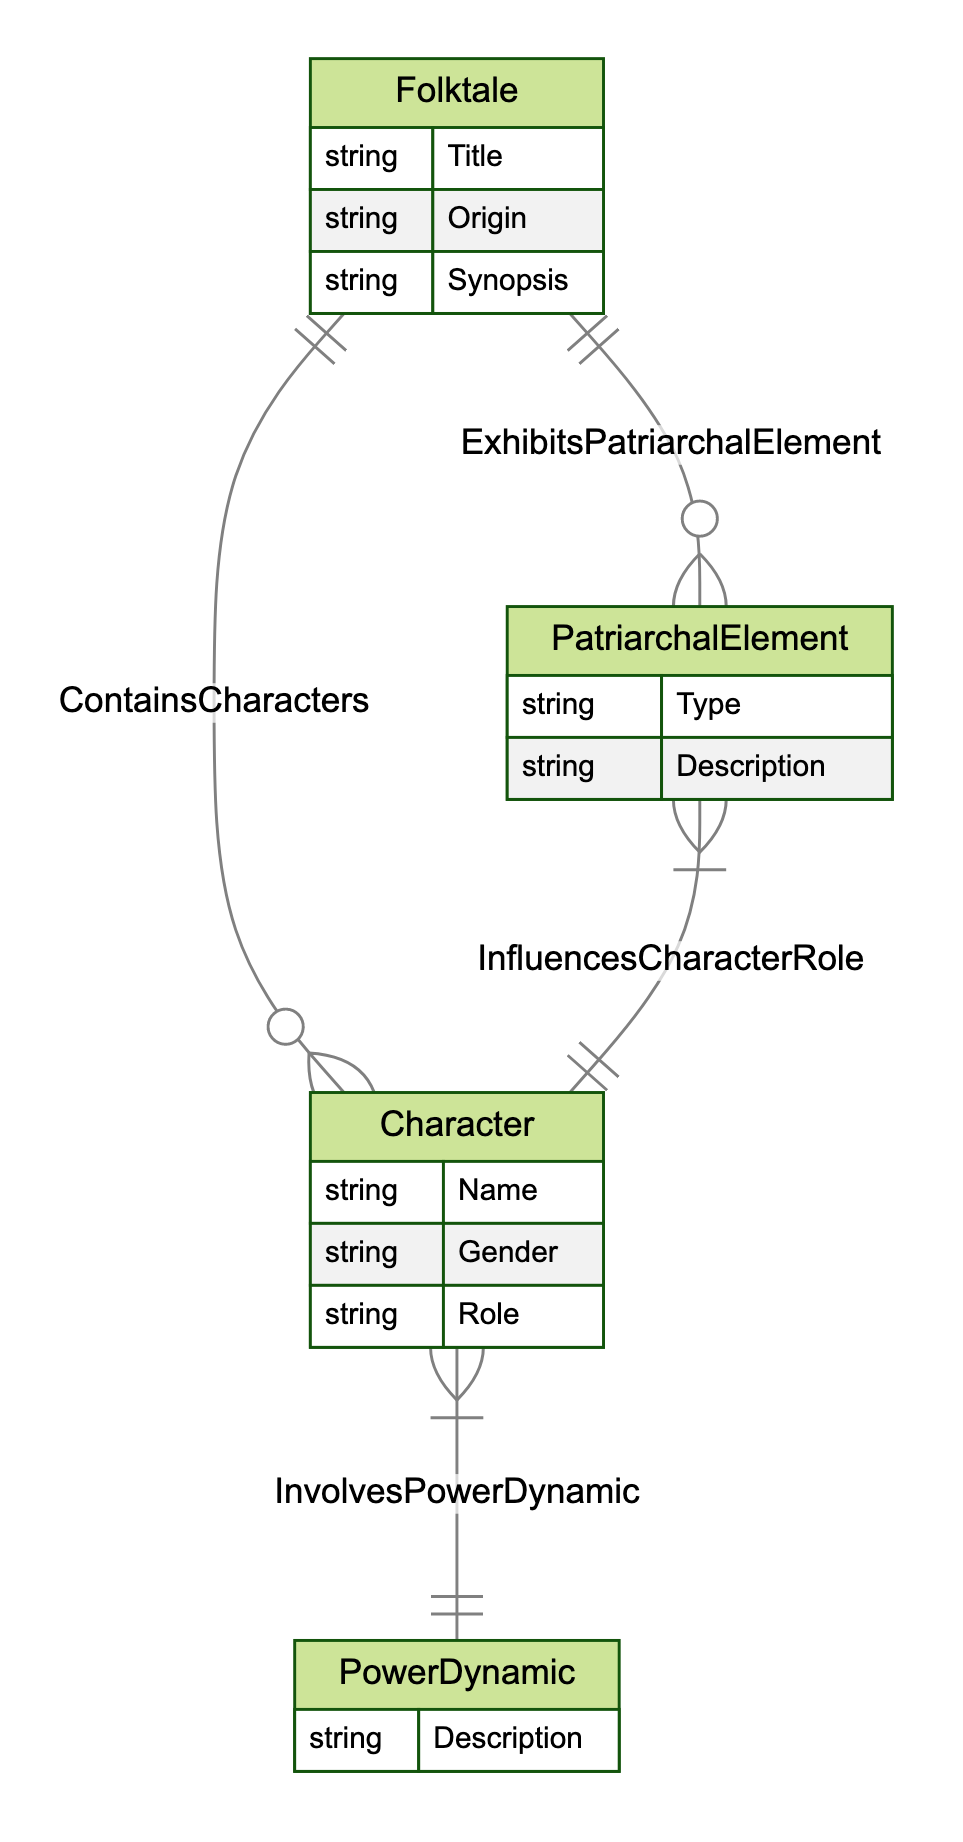What entities are present in the diagram? The diagram includes four entities: Folktale, Character, PatriarchalElement, and PowerDynamic. Each entity is represented with its respective attributes and relationships.
Answer: Folktale, Character, PatriarchalElement, PowerDynamic How many relationships are illustrated in the diagram? The diagram shows four distinct relationships: ContainsCharacters, ExhibitsPatriarchalElement, InvolvesPowerDynamic, and InfluencesCharacterRole. Each relationship connects the entities in a specific manner.
Answer: 4 What is the cardinality between Folktale and Character? The relationship ContainsCharacters has a cardinality of 1-to-many, indicating that one Folktale can include multiple Characters. This is shown directly on the diagram with the relationship line labeled accordingly.
Answer: 1-to-many What describes the relationship between Character and PowerDynamic? The relationship InvolvesPowerDynamic has a many-to-many cardinality, meaning multiple Characters can engage in multiple PowerDynamics, indicating a complex interplay between characters and the dynamics of power.
Answer: many-to-many How does PatriarchalElement influence Character roles? The relationship InfluencesCharacterRole indicates that a PatriarchalElement can affect multiple Character roles, and a Character can be influenced by multiple PatriarchalElements as indicated by the many-to-many cardinality of the relationship.
Answer: many-to-many Which entity has attributes Title, Origin, and Synopsis? The Folktale entity is designed with the attributes Title, Origin, and Synopsis, which provide essential information about each folktale and can be clearly identified in the diagram.
Answer: Folktale What type of element is found in PatriarchalElement? The PatriarchalElement entity includes a Type attribute, which categorizes different aspects of patriarchal structures found in the folktales. This is shown in the diagram, relating it to the overall thematic analysis.
Answer: Type How does the diagram represent the connection between a Folktale and its PatriarchalElements? The ExhibitsPatriarchalElement relationship demonstrates that a Folktale can exhibit multiple PatriarchalElements, illustrated by the 1-to-many cardinality connecting the Folktale and PatriarchalElement entities.
Answer: 1-to-many 